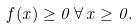Convert formula to latex. <formula><loc_0><loc_0><loc_500><loc_500>f ( x ) \geq 0 \, \forall \, x \geq 0 .</formula> 